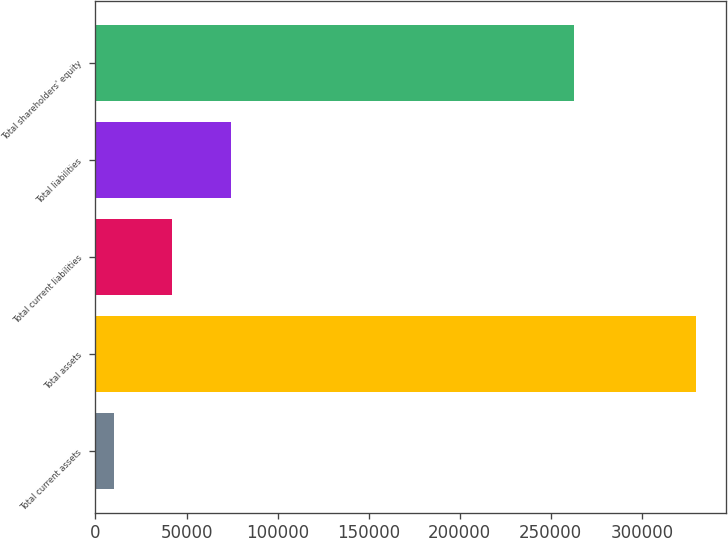Convert chart. <chart><loc_0><loc_0><loc_500><loc_500><bar_chart><fcel>Total current assets<fcel>Total assets<fcel>Total current liabilities<fcel>Total liabilities<fcel>Total shareholders' equity<nl><fcel>10332<fcel>329653<fcel>42264.1<fcel>74196.2<fcel>262566<nl></chart> 